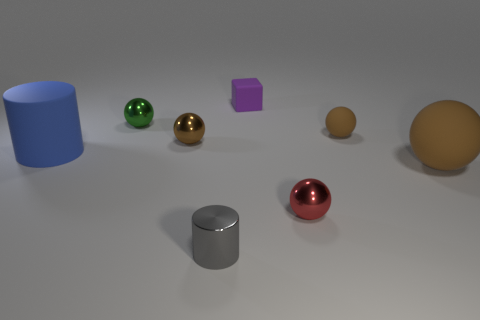What material is the green object that is the same shape as the large brown rubber object?
Ensure brevity in your answer.  Metal. Is there any other thing that has the same size as the blue rubber cylinder?
Your answer should be very brief. Yes. What shape is the big blue rubber object that is left of the tiny purple object?
Offer a terse response. Cylinder. How many other gray metal things are the same shape as the small gray object?
Your answer should be compact. 0. Is the number of gray cylinders to the right of the small purple block the same as the number of large cylinders in front of the small red ball?
Offer a very short reply. Yes. Is there a small red cylinder made of the same material as the purple cube?
Your answer should be compact. No. Do the large blue cylinder and the large brown thing have the same material?
Your answer should be compact. Yes. What number of blue objects are either large rubber cubes or big cylinders?
Provide a short and direct response. 1. Are there more small shiny cylinders on the right side of the purple rubber object than tiny rubber things?
Offer a very short reply. No. Is there a small rubber ball of the same color as the small shiny cylinder?
Ensure brevity in your answer.  No. 